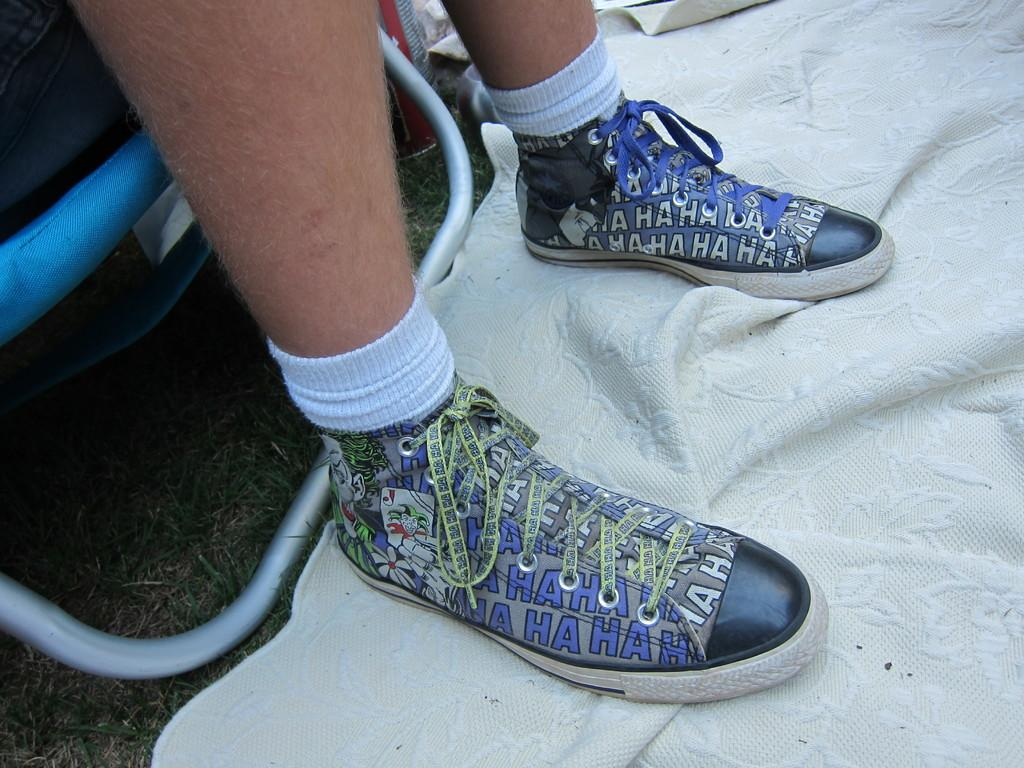What is the main subject of the image? There is a person standing in the image. What is the person standing on? The person is standing on a cloth. What can be seen behind the person in the image? There are objects visible behind the person. What type of stem can be seen growing from the person's head in the image? There is no stem growing from the person's head in the image. What statement or idea is being expressed by the person in the image? The image does not provide any information about a statement or idea being expressed by the person. 